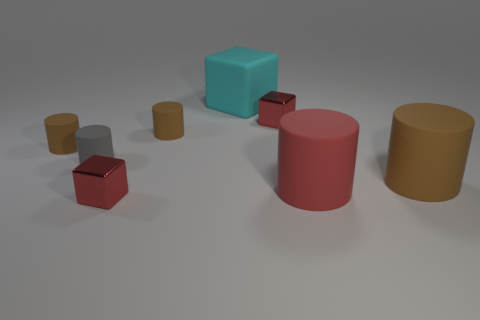What shape is the gray thing that is the same material as the large red cylinder?
Offer a terse response. Cylinder. What is the color of the rubber object behind the metallic cube that is behind the red rubber cylinder?
Make the answer very short. Cyan. There is a small block that is on the left side of the small red shiny thing behind the big brown cylinder that is in front of the big cyan thing; what is it made of?
Your response must be concise. Metal. How many brown matte cylinders have the same size as the matte block?
Give a very brief answer. 1. There is a thing that is in front of the large brown thing and left of the red cylinder; what is its material?
Your response must be concise. Metal. What number of large brown objects are on the left side of the red matte object?
Offer a terse response. 0. Does the small gray object have the same shape as the tiny shiny thing to the right of the big cube?
Make the answer very short. No. Are there any other big objects of the same shape as the gray rubber thing?
Your response must be concise. Yes. There is a red metal object that is behind the tiny metal cube that is to the left of the cyan matte cube; what shape is it?
Provide a short and direct response. Cube. What is the shape of the small red metal thing that is to the right of the large matte cube?
Provide a succinct answer. Cube. 